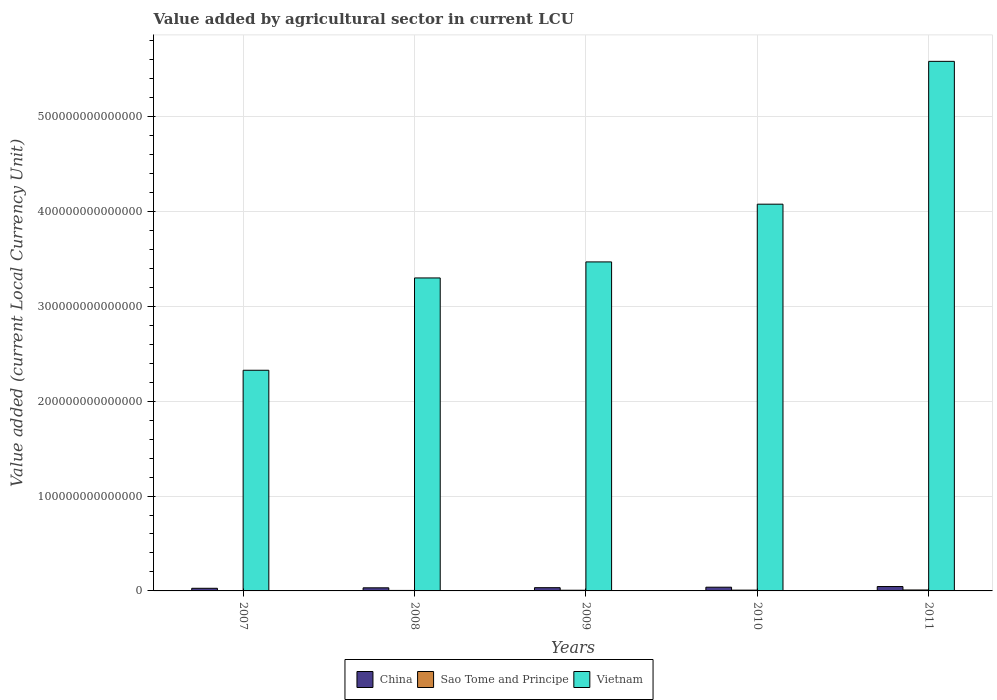How many bars are there on the 4th tick from the right?
Your answer should be very brief. 3. What is the value added by agricultural sector in Sao Tome and Principe in 2010?
Your answer should be very brief. 8.31e+11. Across all years, what is the maximum value added by agricultural sector in Sao Tome and Principe?
Offer a terse response. 9.96e+11. Across all years, what is the minimum value added by agricultural sector in China?
Your answer should be very brief. 2.78e+12. In which year was the value added by agricultural sector in Vietnam maximum?
Offer a terse response. 2011. What is the total value added by agricultural sector in Vietnam in the graph?
Your response must be concise. 1.88e+15. What is the difference between the value added by agricultural sector in China in 2008 and that in 2011?
Offer a terse response. -1.34e+12. What is the difference between the value added by agricultural sector in Vietnam in 2008 and the value added by agricultural sector in China in 2009?
Provide a short and direct response. 3.26e+14. What is the average value added by agricultural sector in Sao Tome and Principe per year?
Give a very brief answer. 6.85e+11. In the year 2011, what is the difference between the value added by agricultural sector in Sao Tome and Principe and value added by agricultural sector in Vietnam?
Keep it short and to the point. -5.57e+14. In how many years, is the value added by agricultural sector in Vietnam greater than 540000000000000 LCU?
Ensure brevity in your answer.  1. What is the ratio of the value added by agricultural sector in Sao Tome and Principe in 2007 to that in 2010?
Make the answer very short. 0.45. Is the value added by agricultural sector in Vietnam in 2008 less than that in 2011?
Your answer should be compact. Yes. What is the difference between the highest and the second highest value added by agricultural sector in Vietnam?
Ensure brevity in your answer.  1.51e+14. What is the difference between the highest and the lowest value added by agricultural sector in China?
Give a very brief answer. 1.84e+12. In how many years, is the value added by agricultural sector in China greater than the average value added by agricultural sector in China taken over all years?
Your answer should be very brief. 2. Is the sum of the value added by agricultural sector in Sao Tome and Principe in 2010 and 2011 greater than the maximum value added by agricultural sector in Vietnam across all years?
Make the answer very short. No. What does the 3rd bar from the left in 2010 represents?
Ensure brevity in your answer.  Vietnam. What does the 2nd bar from the right in 2008 represents?
Your response must be concise. Sao Tome and Principe. Is it the case that in every year, the sum of the value added by agricultural sector in China and value added by agricultural sector in Sao Tome and Principe is greater than the value added by agricultural sector in Vietnam?
Provide a short and direct response. No. How many years are there in the graph?
Provide a succinct answer. 5. What is the difference between two consecutive major ticks on the Y-axis?
Your answer should be compact. 1.00e+14. Does the graph contain grids?
Keep it short and to the point. Yes. How many legend labels are there?
Offer a very short reply. 3. How are the legend labels stacked?
Make the answer very short. Horizontal. What is the title of the graph?
Offer a very short reply. Value added by agricultural sector in current LCU. Does "Canada" appear as one of the legend labels in the graph?
Your response must be concise. No. What is the label or title of the Y-axis?
Provide a short and direct response. Value added (current Local Currency Unit). What is the Value added (current Local Currency Unit) of China in 2007?
Provide a succinct answer. 2.78e+12. What is the Value added (current Local Currency Unit) of Sao Tome and Principe in 2007?
Your answer should be compact. 3.72e+11. What is the Value added (current Local Currency Unit) in Vietnam in 2007?
Give a very brief answer. 2.33e+14. What is the Value added (current Local Currency Unit) in China in 2008?
Your response must be concise. 3.27e+12. What is the Value added (current Local Currency Unit) of Sao Tome and Principe in 2008?
Your answer should be very brief. 5.11e+11. What is the Value added (current Local Currency Unit) of Vietnam in 2008?
Keep it short and to the point. 3.30e+14. What is the Value added (current Local Currency Unit) in China in 2009?
Keep it short and to the point. 3.42e+12. What is the Value added (current Local Currency Unit) of Sao Tome and Principe in 2009?
Make the answer very short. 7.16e+11. What is the Value added (current Local Currency Unit) of Vietnam in 2009?
Ensure brevity in your answer.  3.47e+14. What is the Value added (current Local Currency Unit) of China in 2010?
Make the answer very short. 3.94e+12. What is the Value added (current Local Currency Unit) of Sao Tome and Principe in 2010?
Your answer should be very brief. 8.31e+11. What is the Value added (current Local Currency Unit) of Vietnam in 2010?
Give a very brief answer. 4.08e+14. What is the Value added (current Local Currency Unit) in China in 2011?
Give a very brief answer. 4.62e+12. What is the Value added (current Local Currency Unit) in Sao Tome and Principe in 2011?
Offer a terse response. 9.96e+11. What is the Value added (current Local Currency Unit) of Vietnam in 2011?
Ensure brevity in your answer.  5.58e+14. Across all years, what is the maximum Value added (current Local Currency Unit) in China?
Your answer should be very brief. 4.62e+12. Across all years, what is the maximum Value added (current Local Currency Unit) in Sao Tome and Principe?
Keep it short and to the point. 9.96e+11. Across all years, what is the maximum Value added (current Local Currency Unit) in Vietnam?
Your answer should be compact. 5.58e+14. Across all years, what is the minimum Value added (current Local Currency Unit) of China?
Give a very brief answer. 2.78e+12. Across all years, what is the minimum Value added (current Local Currency Unit) of Sao Tome and Principe?
Ensure brevity in your answer.  3.72e+11. Across all years, what is the minimum Value added (current Local Currency Unit) of Vietnam?
Your response must be concise. 2.33e+14. What is the total Value added (current Local Currency Unit) in China in the graph?
Your response must be concise. 1.80e+13. What is the total Value added (current Local Currency Unit) in Sao Tome and Principe in the graph?
Offer a terse response. 3.43e+12. What is the total Value added (current Local Currency Unit) in Vietnam in the graph?
Provide a short and direct response. 1.88e+15. What is the difference between the Value added (current Local Currency Unit) of China in 2007 and that in 2008?
Make the answer very short. -4.96e+11. What is the difference between the Value added (current Local Currency Unit) of Sao Tome and Principe in 2007 and that in 2008?
Keep it short and to the point. -1.39e+11. What is the difference between the Value added (current Local Currency Unit) in Vietnam in 2007 and that in 2008?
Give a very brief answer. -9.73e+13. What is the difference between the Value added (current Local Currency Unit) in China in 2007 and that in 2009?
Provide a succinct answer. -6.37e+11. What is the difference between the Value added (current Local Currency Unit) of Sao Tome and Principe in 2007 and that in 2009?
Provide a succinct answer. -3.44e+11. What is the difference between the Value added (current Local Currency Unit) of Vietnam in 2007 and that in 2009?
Offer a terse response. -1.14e+14. What is the difference between the Value added (current Local Currency Unit) of China in 2007 and that in 2010?
Your response must be concise. -1.16e+12. What is the difference between the Value added (current Local Currency Unit) in Sao Tome and Principe in 2007 and that in 2010?
Your response must be concise. -4.60e+11. What is the difference between the Value added (current Local Currency Unit) in Vietnam in 2007 and that in 2010?
Ensure brevity in your answer.  -1.75e+14. What is the difference between the Value added (current Local Currency Unit) of China in 2007 and that in 2011?
Offer a very short reply. -1.84e+12. What is the difference between the Value added (current Local Currency Unit) of Sao Tome and Principe in 2007 and that in 2011?
Provide a short and direct response. -6.24e+11. What is the difference between the Value added (current Local Currency Unit) of Vietnam in 2007 and that in 2011?
Give a very brief answer. -3.26e+14. What is the difference between the Value added (current Local Currency Unit) of China in 2008 and that in 2009?
Offer a terse response. -1.41e+11. What is the difference between the Value added (current Local Currency Unit) in Sao Tome and Principe in 2008 and that in 2009?
Provide a succinct answer. -2.05e+11. What is the difference between the Value added (current Local Currency Unit) of Vietnam in 2008 and that in 2009?
Keep it short and to the point. -1.69e+13. What is the difference between the Value added (current Local Currency Unit) in China in 2008 and that in 2010?
Your answer should be compact. -6.61e+11. What is the difference between the Value added (current Local Currency Unit) of Sao Tome and Principe in 2008 and that in 2010?
Your answer should be very brief. -3.21e+11. What is the difference between the Value added (current Local Currency Unit) in Vietnam in 2008 and that in 2010?
Offer a terse response. -7.78e+13. What is the difference between the Value added (current Local Currency Unit) in China in 2008 and that in 2011?
Your answer should be very brief. -1.34e+12. What is the difference between the Value added (current Local Currency Unit) of Sao Tome and Principe in 2008 and that in 2011?
Provide a short and direct response. -4.85e+11. What is the difference between the Value added (current Local Currency Unit) in Vietnam in 2008 and that in 2011?
Make the answer very short. -2.28e+14. What is the difference between the Value added (current Local Currency Unit) in China in 2009 and that in 2010?
Your response must be concise. -5.20e+11. What is the difference between the Value added (current Local Currency Unit) in Sao Tome and Principe in 2009 and that in 2010?
Make the answer very short. -1.15e+11. What is the difference between the Value added (current Local Currency Unit) of Vietnam in 2009 and that in 2010?
Provide a short and direct response. -6.09e+13. What is the difference between the Value added (current Local Currency Unit) of China in 2009 and that in 2011?
Make the answer very short. -1.20e+12. What is the difference between the Value added (current Local Currency Unit) in Sao Tome and Principe in 2009 and that in 2011?
Offer a very short reply. -2.80e+11. What is the difference between the Value added (current Local Currency Unit) of Vietnam in 2009 and that in 2011?
Make the answer very short. -2.11e+14. What is the difference between the Value added (current Local Currency Unit) of China in 2010 and that in 2011?
Keep it short and to the point. -6.80e+11. What is the difference between the Value added (current Local Currency Unit) of Sao Tome and Principe in 2010 and that in 2011?
Your answer should be very brief. -1.64e+11. What is the difference between the Value added (current Local Currency Unit) in Vietnam in 2010 and that in 2011?
Provide a short and direct response. -1.51e+14. What is the difference between the Value added (current Local Currency Unit) in China in 2007 and the Value added (current Local Currency Unit) in Sao Tome and Principe in 2008?
Your response must be concise. 2.27e+12. What is the difference between the Value added (current Local Currency Unit) in China in 2007 and the Value added (current Local Currency Unit) in Vietnam in 2008?
Ensure brevity in your answer.  -3.27e+14. What is the difference between the Value added (current Local Currency Unit) in Sao Tome and Principe in 2007 and the Value added (current Local Currency Unit) in Vietnam in 2008?
Make the answer very short. -3.30e+14. What is the difference between the Value added (current Local Currency Unit) in China in 2007 and the Value added (current Local Currency Unit) in Sao Tome and Principe in 2009?
Offer a terse response. 2.06e+12. What is the difference between the Value added (current Local Currency Unit) of China in 2007 and the Value added (current Local Currency Unit) of Vietnam in 2009?
Your answer should be very brief. -3.44e+14. What is the difference between the Value added (current Local Currency Unit) of Sao Tome and Principe in 2007 and the Value added (current Local Currency Unit) of Vietnam in 2009?
Keep it short and to the point. -3.46e+14. What is the difference between the Value added (current Local Currency Unit) of China in 2007 and the Value added (current Local Currency Unit) of Sao Tome and Principe in 2010?
Your answer should be compact. 1.95e+12. What is the difference between the Value added (current Local Currency Unit) of China in 2007 and the Value added (current Local Currency Unit) of Vietnam in 2010?
Your answer should be compact. -4.05e+14. What is the difference between the Value added (current Local Currency Unit) in Sao Tome and Principe in 2007 and the Value added (current Local Currency Unit) in Vietnam in 2010?
Offer a terse response. -4.07e+14. What is the difference between the Value added (current Local Currency Unit) of China in 2007 and the Value added (current Local Currency Unit) of Sao Tome and Principe in 2011?
Provide a short and direct response. 1.78e+12. What is the difference between the Value added (current Local Currency Unit) of China in 2007 and the Value added (current Local Currency Unit) of Vietnam in 2011?
Provide a succinct answer. -5.55e+14. What is the difference between the Value added (current Local Currency Unit) in Sao Tome and Principe in 2007 and the Value added (current Local Currency Unit) in Vietnam in 2011?
Provide a succinct answer. -5.58e+14. What is the difference between the Value added (current Local Currency Unit) of China in 2008 and the Value added (current Local Currency Unit) of Sao Tome and Principe in 2009?
Offer a very short reply. 2.56e+12. What is the difference between the Value added (current Local Currency Unit) in China in 2008 and the Value added (current Local Currency Unit) in Vietnam in 2009?
Offer a terse response. -3.44e+14. What is the difference between the Value added (current Local Currency Unit) of Sao Tome and Principe in 2008 and the Value added (current Local Currency Unit) of Vietnam in 2009?
Your response must be concise. -3.46e+14. What is the difference between the Value added (current Local Currency Unit) in China in 2008 and the Value added (current Local Currency Unit) in Sao Tome and Principe in 2010?
Your answer should be compact. 2.44e+12. What is the difference between the Value added (current Local Currency Unit) in China in 2008 and the Value added (current Local Currency Unit) in Vietnam in 2010?
Offer a very short reply. -4.04e+14. What is the difference between the Value added (current Local Currency Unit) in Sao Tome and Principe in 2008 and the Value added (current Local Currency Unit) in Vietnam in 2010?
Give a very brief answer. -4.07e+14. What is the difference between the Value added (current Local Currency Unit) in China in 2008 and the Value added (current Local Currency Unit) in Sao Tome and Principe in 2011?
Provide a succinct answer. 2.28e+12. What is the difference between the Value added (current Local Currency Unit) of China in 2008 and the Value added (current Local Currency Unit) of Vietnam in 2011?
Keep it short and to the point. -5.55e+14. What is the difference between the Value added (current Local Currency Unit) of Sao Tome and Principe in 2008 and the Value added (current Local Currency Unit) of Vietnam in 2011?
Your response must be concise. -5.58e+14. What is the difference between the Value added (current Local Currency Unit) of China in 2009 and the Value added (current Local Currency Unit) of Sao Tome and Principe in 2010?
Offer a terse response. 2.58e+12. What is the difference between the Value added (current Local Currency Unit) of China in 2009 and the Value added (current Local Currency Unit) of Vietnam in 2010?
Your answer should be compact. -4.04e+14. What is the difference between the Value added (current Local Currency Unit) of Sao Tome and Principe in 2009 and the Value added (current Local Currency Unit) of Vietnam in 2010?
Ensure brevity in your answer.  -4.07e+14. What is the difference between the Value added (current Local Currency Unit) in China in 2009 and the Value added (current Local Currency Unit) in Sao Tome and Principe in 2011?
Provide a short and direct response. 2.42e+12. What is the difference between the Value added (current Local Currency Unit) of China in 2009 and the Value added (current Local Currency Unit) of Vietnam in 2011?
Your answer should be compact. -5.55e+14. What is the difference between the Value added (current Local Currency Unit) of Sao Tome and Principe in 2009 and the Value added (current Local Currency Unit) of Vietnam in 2011?
Give a very brief answer. -5.57e+14. What is the difference between the Value added (current Local Currency Unit) in China in 2010 and the Value added (current Local Currency Unit) in Sao Tome and Principe in 2011?
Make the answer very short. 2.94e+12. What is the difference between the Value added (current Local Currency Unit) in China in 2010 and the Value added (current Local Currency Unit) in Vietnam in 2011?
Offer a terse response. -5.54e+14. What is the difference between the Value added (current Local Currency Unit) of Sao Tome and Principe in 2010 and the Value added (current Local Currency Unit) of Vietnam in 2011?
Your answer should be compact. -5.57e+14. What is the average Value added (current Local Currency Unit) in China per year?
Your response must be concise. 3.60e+12. What is the average Value added (current Local Currency Unit) of Sao Tome and Principe per year?
Make the answer very short. 6.85e+11. What is the average Value added (current Local Currency Unit) in Vietnam per year?
Your answer should be compact. 3.75e+14. In the year 2007, what is the difference between the Value added (current Local Currency Unit) of China and Value added (current Local Currency Unit) of Sao Tome and Principe?
Your answer should be very brief. 2.41e+12. In the year 2007, what is the difference between the Value added (current Local Currency Unit) in China and Value added (current Local Currency Unit) in Vietnam?
Give a very brief answer. -2.30e+14. In the year 2007, what is the difference between the Value added (current Local Currency Unit) of Sao Tome and Principe and Value added (current Local Currency Unit) of Vietnam?
Give a very brief answer. -2.32e+14. In the year 2008, what is the difference between the Value added (current Local Currency Unit) of China and Value added (current Local Currency Unit) of Sao Tome and Principe?
Provide a short and direct response. 2.76e+12. In the year 2008, what is the difference between the Value added (current Local Currency Unit) of China and Value added (current Local Currency Unit) of Vietnam?
Ensure brevity in your answer.  -3.27e+14. In the year 2008, what is the difference between the Value added (current Local Currency Unit) of Sao Tome and Principe and Value added (current Local Currency Unit) of Vietnam?
Your answer should be compact. -3.29e+14. In the year 2009, what is the difference between the Value added (current Local Currency Unit) in China and Value added (current Local Currency Unit) in Sao Tome and Principe?
Your response must be concise. 2.70e+12. In the year 2009, what is the difference between the Value added (current Local Currency Unit) in China and Value added (current Local Currency Unit) in Vietnam?
Offer a terse response. -3.43e+14. In the year 2009, what is the difference between the Value added (current Local Currency Unit) of Sao Tome and Principe and Value added (current Local Currency Unit) of Vietnam?
Keep it short and to the point. -3.46e+14. In the year 2010, what is the difference between the Value added (current Local Currency Unit) in China and Value added (current Local Currency Unit) in Sao Tome and Principe?
Ensure brevity in your answer.  3.10e+12. In the year 2010, what is the difference between the Value added (current Local Currency Unit) in China and Value added (current Local Currency Unit) in Vietnam?
Offer a very short reply. -4.04e+14. In the year 2010, what is the difference between the Value added (current Local Currency Unit) in Sao Tome and Principe and Value added (current Local Currency Unit) in Vietnam?
Provide a succinct answer. -4.07e+14. In the year 2011, what is the difference between the Value added (current Local Currency Unit) of China and Value added (current Local Currency Unit) of Sao Tome and Principe?
Give a very brief answer. 3.62e+12. In the year 2011, what is the difference between the Value added (current Local Currency Unit) in China and Value added (current Local Currency Unit) in Vietnam?
Provide a succinct answer. -5.54e+14. In the year 2011, what is the difference between the Value added (current Local Currency Unit) in Sao Tome and Principe and Value added (current Local Currency Unit) in Vietnam?
Provide a short and direct response. -5.57e+14. What is the ratio of the Value added (current Local Currency Unit) in China in 2007 to that in 2008?
Provide a succinct answer. 0.85. What is the ratio of the Value added (current Local Currency Unit) of Sao Tome and Principe in 2007 to that in 2008?
Provide a succinct answer. 0.73. What is the ratio of the Value added (current Local Currency Unit) in Vietnam in 2007 to that in 2008?
Make the answer very short. 0.7. What is the ratio of the Value added (current Local Currency Unit) of China in 2007 to that in 2009?
Offer a very short reply. 0.81. What is the ratio of the Value added (current Local Currency Unit) in Sao Tome and Principe in 2007 to that in 2009?
Your answer should be compact. 0.52. What is the ratio of the Value added (current Local Currency Unit) in Vietnam in 2007 to that in 2009?
Provide a succinct answer. 0.67. What is the ratio of the Value added (current Local Currency Unit) in China in 2007 to that in 2010?
Provide a short and direct response. 0.71. What is the ratio of the Value added (current Local Currency Unit) in Sao Tome and Principe in 2007 to that in 2010?
Provide a succinct answer. 0.45. What is the ratio of the Value added (current Local Currency Unit) of Vietnam in 2007 to that in 2010?
Make the answer very short. 0.57. What is the ratio of the Value added (current Local Currency Unit) of China in 2007 to that in 2011?
Keep it short and to the point. 0.6. What is the ratio of the Value added (current Local Currency Unit) of Sao Tome and Principe in 2007 to that in 2011?
Offer a very short reply. 0.37. What is the ratio of the Value added (current Local Currency Unit) in Vietnam in 2007 to that in 2011?
Offer a terse response. 0.42. What is the ratio of the Value added (current Local Currency Unit) of China in 2008 to that in 2009?
Offer a very short reply. 0.96. What is the ratio of the Value added (current Local Currency Unit) of Sao Tome and Principe in 2008 to that in 2009?
Provide a succinct answer. 0.71. What is the ratio of the Value added (current Local Currency Unit) of Vietnam in 2008 to that in 2009?
Your response must be concise. 0.95. What is the ratio of the Value added (current Local Currency Unit) in China in 2008 to that in 2010?
Keep it short and to the point. 0.83. What is the ratio of the Value added (current Local Currency Unit) in Sao Tome and Principe in 2008 to that in 2010?
Provide a succinct answer. 0.61. What is the ratio of the Value added (current Local Currency Unit) in Vietnam in 2008 to that in 2010?
Provide a short and direct response. 0.81. What is the ratio of the Value added (current Local Currency Unit) in China in 2008 to that in 2011?
Provide a short and direct response. 0.71. What is the ratio of the Value added (current Local Currency Unit) in Sao Tome and Principe in 2008 to that in 2011?
Provide a short and direct response. 0.51. What is the ratio of the Value added (current Local Currency Unit) in Vietnam in 2008 to that in 2011?
Offer a very short reply. 0.59. What is the ratio of the Value added (current Local Currency Unit) in China in 2009 to that in 2010?
Provide a succinct answer. 0.87. What is the ratio of the Value added (current Local Currency Unit) of Sao Tome and Principe in 2009 to that in 2010?
Your answer should be very brief. 0.86. What is the ratio of the Value added (current Local Currency Unit) of Vietnam in 2009 to that in 2010?
Provide a succinct answer. 0.85. What is the ratio of the Value added (current Local Currency Unit) of China in 2009 to that in 2011?
Make the answer very short. 0.74. What is the ratio of the Value added (current Local Currency Unit) of Sao Tome and Principe in 2009 to that in 2011?
Make the answer very short. 0.72. What is the ratio of the Value added (current Local Currency Unit) in Vietnam in 2009 to that in 2011?
Your answer should be compact. 0.62. What is the ratio of the Value added (current Local Currency Unit) in China in 2010 to that in 2011?
Make the answer very short. 0.85. What is the ratio of the Value added (current Local Currency Unit) in Sao Tome and Principe in 2010 to that in 2011?
Keep it short and to the point. 0.83. What is the ratio of the Value added (current Local Currency Unit) in Vietnam in 2010 to that in 2011?
Make the answer very short. 0.73. What is the difference between the highest and the second highest Value added (current Local Currency Unit) in China?
Offer a terse response. 6.80e+11. What is the difference between the highest and the second highest Value added (current Local Currency Unit) in Sao Tome and Principe?
Keep it short and to the point. 1.64e+11. What is the difference between the highest and the second highest Value added (current Local Currency Unit) of Vietnam?
Provide a short and direct response. 1.51e+14. What is the difference between the highest and the lowest Value added (current Local Currency Unit) of China?
Your answer should be compact. 1.84e+12. What is the difference between the highest and the lowest Value added (current Local Currency Unit) in Sao Tome and Principe?
Your response must be concise. 6.24e+11. What is the difference between the highest and the lowest Value added (current Local Currency Unit) in Vietnam?
Give a very brief answer. 3.26e+14. 